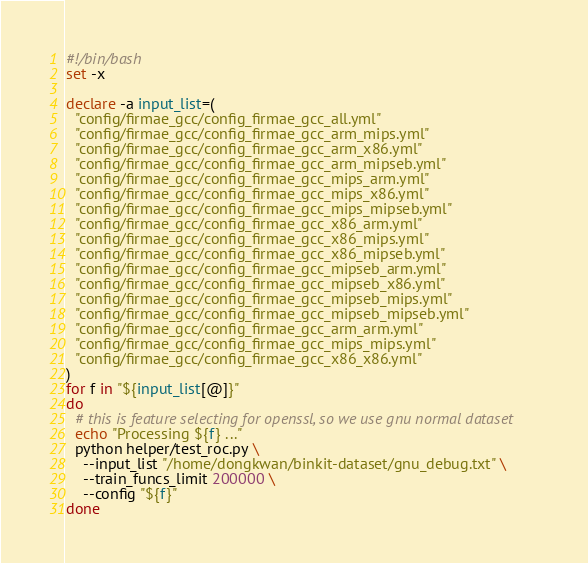<code> <loc_0><loc_0><loc_500><loc_500><_Bash_>#!/bin/bash
set -x

declare -a input_list=(
  "config/firmae_gcc/config_firmae_gcc_all.yml"
  "config/firmae_gcc/config_firmae_gcc_arm_mips.yml"
  "config/firmae_gcc/config_firmae_gcc_arm_x86.yml"
  "config/firmae_gcc/config_firmae_gcc_arm_mipseb.yml"
  "config/firmae_gcc/config_firmae_gcc_mips_arm.yml"
  "config/firmae_gcc/config_firmae_gcc_mips_x86.yml"
  "config/firmae_gcc/config_firmae_gcc_mips_mipseb.yml"
  "config/firmae_gcc/config_firmae_gcc_x86_arm.yml"
  "config/firmae_gcc/config_firmae_gcc_x86_mips.yml"
  "config/firmae_gcc/config_firmae_gcc_x86_mipseb.yml"
  "config/firmae_gcc/config_firmae_gcc_mipseb_arm.yml"
  "config/firmae_gcc/config_firmae_gcc_mipseb_x86.yml"
  "config/firmae_gcc/config_firmae_gcc_mipseb_mips.yml"
  "config/firmae_gcc/config_firmae_gcc_mipseb_mipseb.yml"
  "config/firmae_gcc/config_firmae_gcc_arm_arm.yml"
  "config/firmae_gcc/config_firmae_gcc_mips_mips.yml"
  "config/firmae_gcc/config_firmae_gcc_x86_x86.yml"
)
for f in "${input_list[@]}"
do
  # this is feature selecting for openssl, so we use gnu normal dataset
  echo "Processing ${f} ..."
  python helper/test_roc.py \
    --input_list "/home/dongkwan/binkit-dataset/gnu_debug.txt" \
    --train_funcs_limit 200000 \
    --config "${f}"
done
</code> 